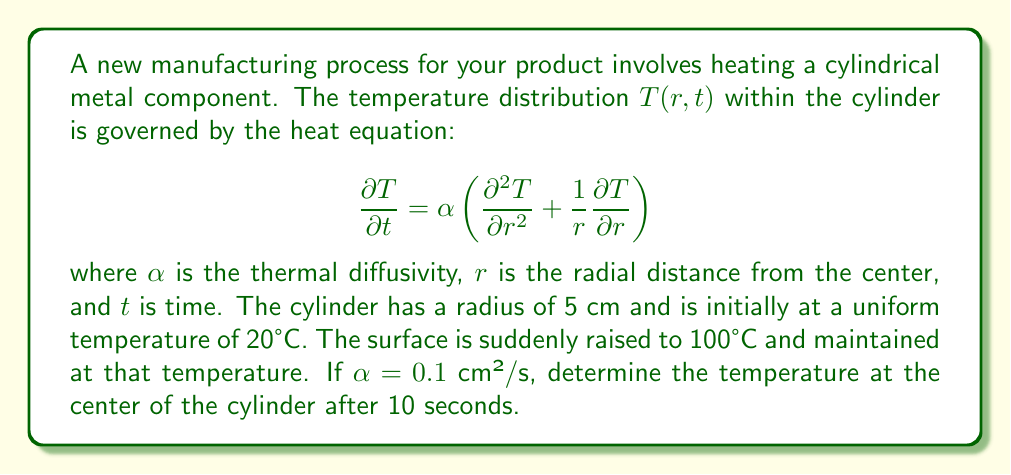Help me with this question. To solve this problem, we need to use the solution to the heat equation for a cylinder with constant surface temperature. The solution is given by:

$$T(r,t) = T_s + (T_0 - T_s)\sum_{n=1}^{\infty}\frac{2}{a\lambda_n J_1(a\lambda_n)}J_0(r\lambda_n)e^{-\alpha\lambda_n^2t}$$

Where:
- $T_s$ is the surface temperature (100°C)
- $T_0$ is the initial temperature (20°C)
- $a$ is the radius of the cylinder (5 cm)
- $J_0$ and $J_1$ are Bessel functions of the first kind of order 0 and 1
- $\lambda_n$ are the positive roots of $J_0(a\lambda_n) = 0$

Steps to solve:

1) First, we need to find the first few roots of $J_0(5\lambda_n) = 0$. Using a mathematical software or tables, we get:
   $\lambda_1 \approx 0.7656$ cm⁻¹, $\lambda_2 \approx 1.7571$ cm⁻¹, $\lambda_3 \approx 2.7546$ cm⁻¹

2) At the center of the cylinder, $r = 0$. Note that $J_0(0) = 1$.

3) Substituting the values into the equation:

   $$T(0,10) = 100 + (20 - 100)\sum_{n=1}^{\infty}\frac{2}{5\lambda_n J_1(5\lambda_n)}e^{-0.1\lambda_n^2 \cdot 10}$$

4) Calculate the first three terms of the series:

   Term 1: $\frac{2}{5 \cdot 0.7656 \cdot J_1(3.828)} e^{-0.1 \cdot 0.7656^2 \cdot 10} \approx 0.5413$
   Term 2: $\frac{2}{5 \cdot 1.7571 \cdot J_1(8.7855)} e^{-0.1 \cdot 1.7571^2 \cdot 10} \approx 0.0018$
   Term 3: $\frac{2}{5 \cdot 2.7546 \cdot J_1(13.773)} e^{-0.1 \cdot 2.7546^2 \cdot 10} \approx 0.0000$

5) Sum the terms: $0.5413 + 0.0018 + 0.0000 \approx 0.5431$

6) Final calculation:
   $T(0,10) = 100 + (20 - 100) \cdot 0.5431 = 56.55°C$
Answer: 56.55°C 